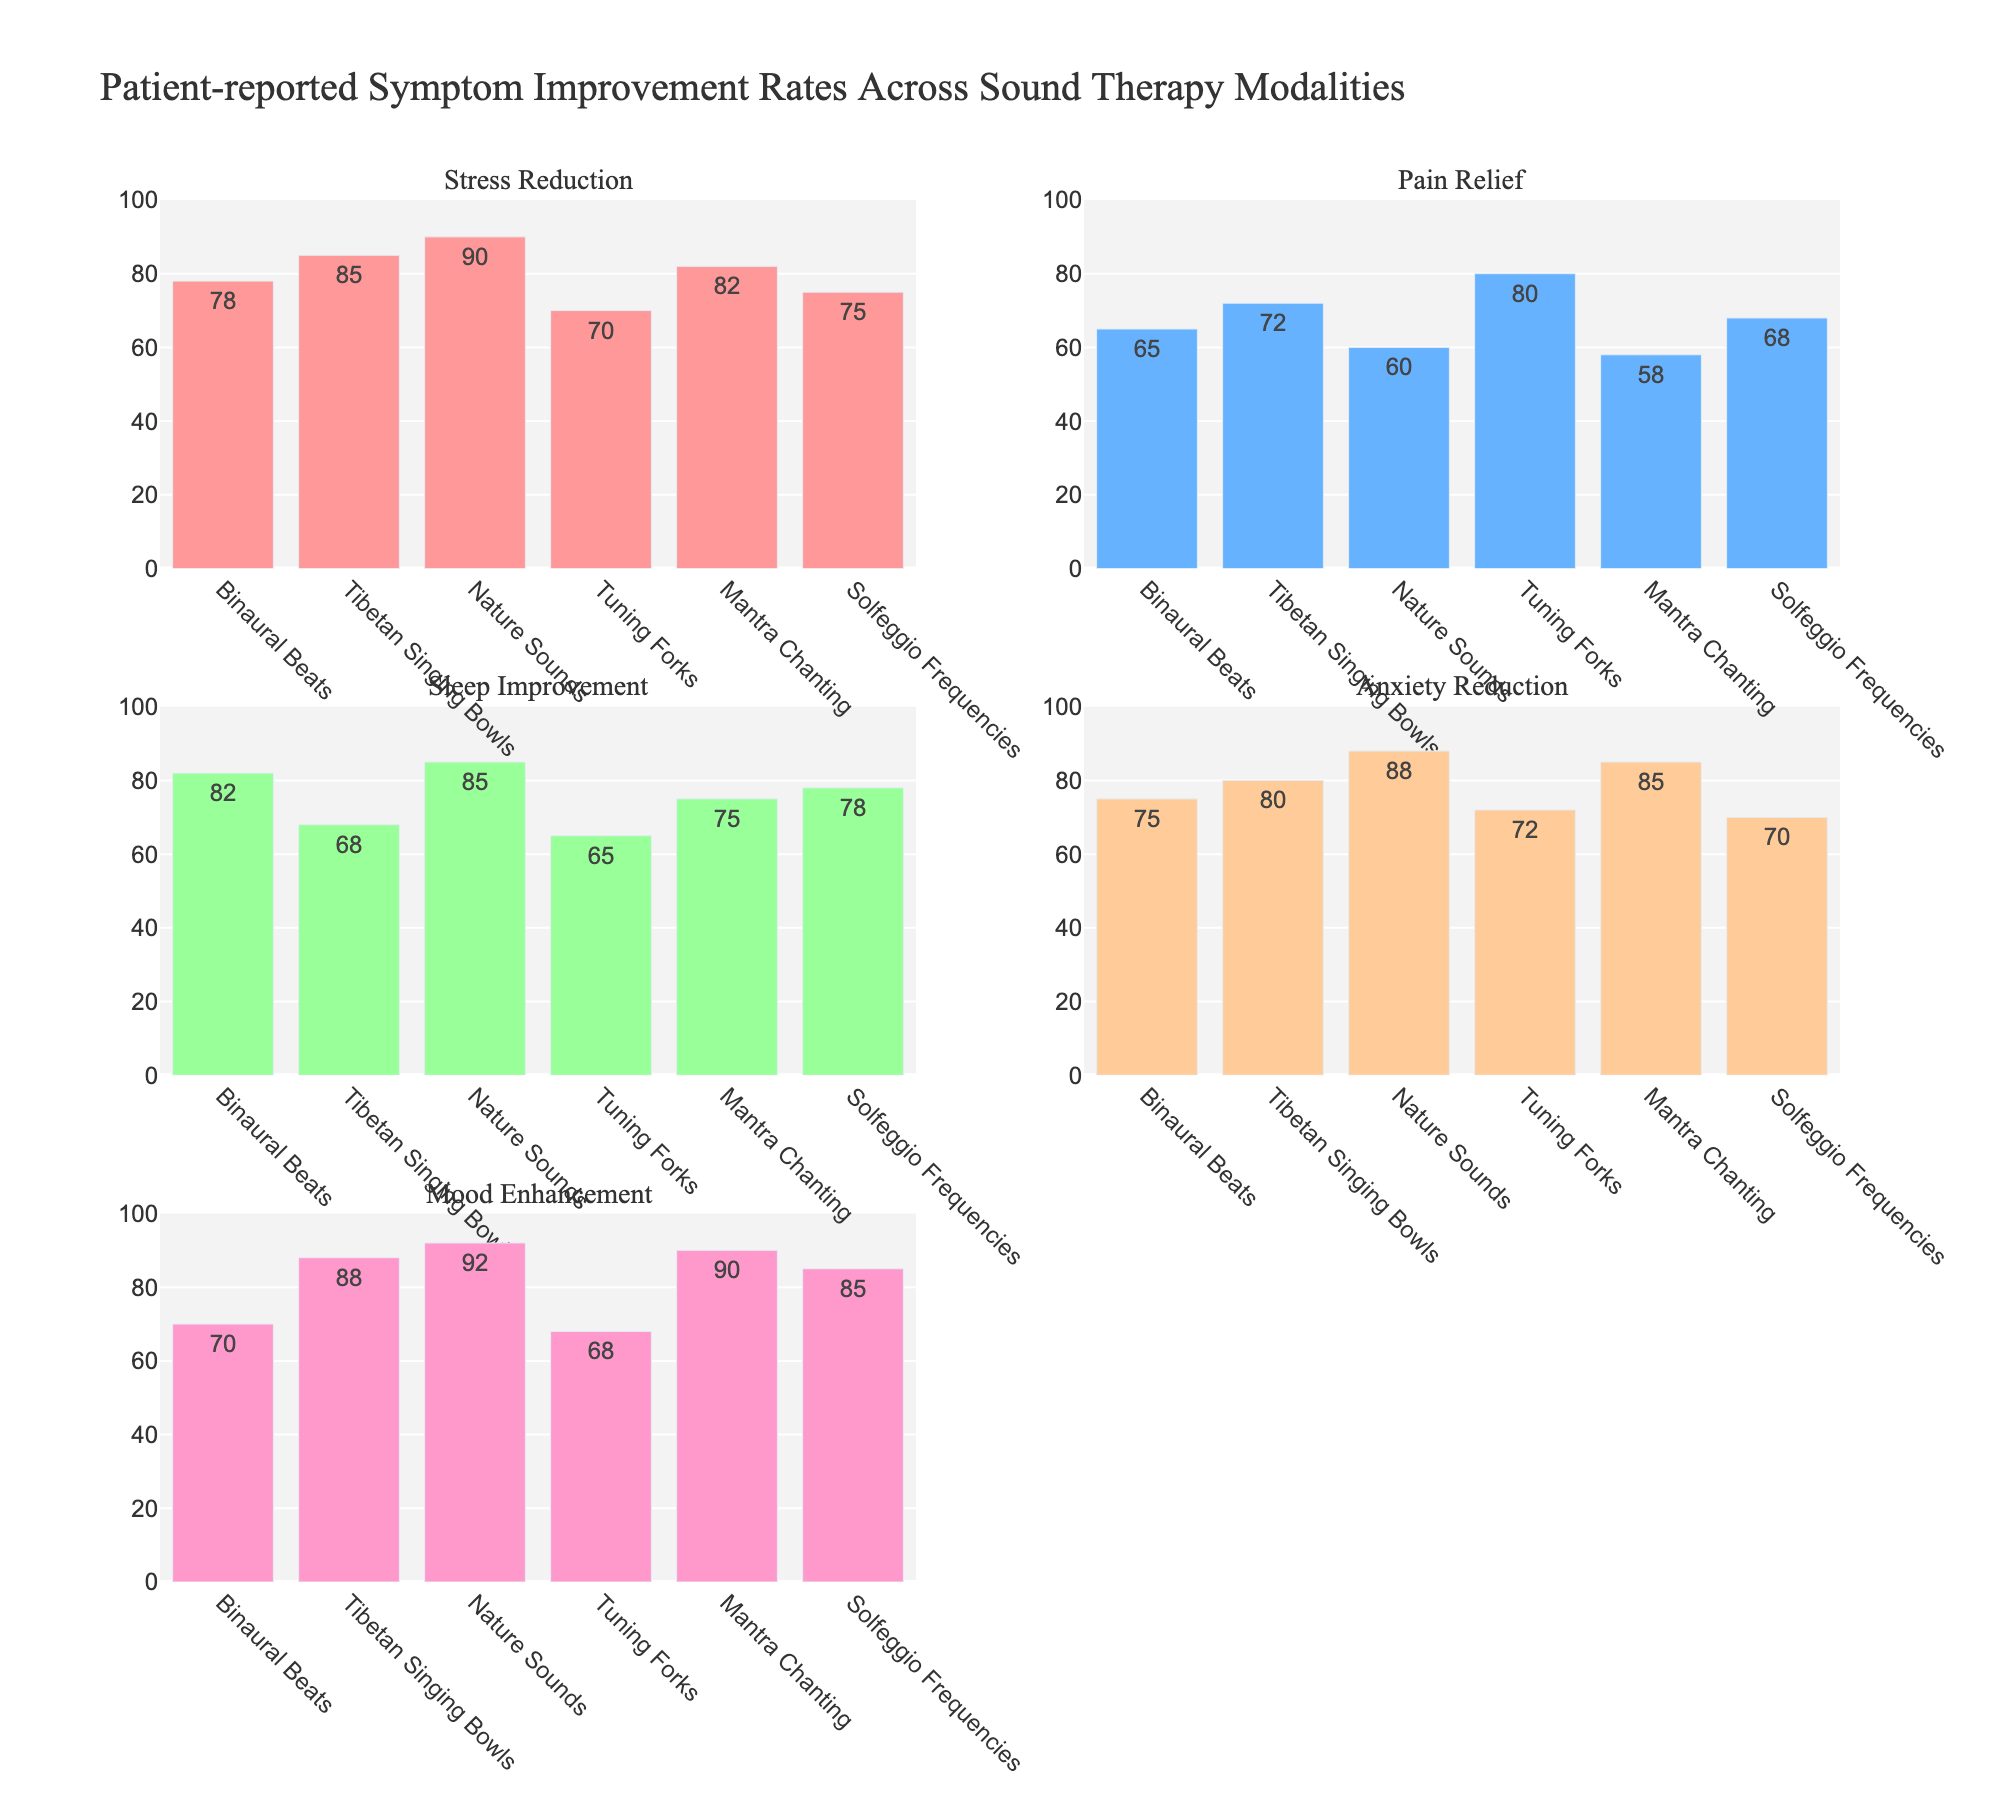What is the overall title of the figure? The overall title is displayed prominently at the top of the figure and summarizes the content of the subplots.
Answer: Patient-reported Symptom Improvement Rates Across Sound Therapy Modalities Which modality has the highest improvement rate for Stress Reduction? To determine the highest improvement rate for Stress Reduction, observe the first subplot. Find the tallest bar, which corresponds to the modality with the highest rate.
Answer: Nature Sounds How many subplots are in the figure? Counting each individual bar chart within the figure helps to determine the total number of subplots.
Answer: 5 Which modality shows the lowest improvement rate for Mood Enhancement? In the Mood Enhancement subplot, identify the shortest bar to determine the modality with the lowest improvement rate.
Answer: Tuning Forks Which symptoms are displayed in the second column of the subplots? The second column contains two subplots. By examining their titles, we can identify which symptoms they represent.
Answer: Pain Relief and Anxiety Reduction What is the average improvement rate for Sleep Improvement across all modalities? Add up all the improvement rates for Sleep Improvement from each modality and divide by the total number of modalities. (82 + 68 + 85 + 65 + 75 + 78) / 6 = 453 / 6
Answer: 75.5% How does the improvement rate for Pain Relief compare between Tibetan Singing Bowls and Tuning Forks? Look at the Pain Relief subplot and compare the heights of the bars for Tibetan Singing Bowls and Tuning Forks.
Answer: Tuning Forks has a higher rate (80) compared to Tibetan Singing Bowls (72) Which modality has consistently high improvement rates across all symptoms? By observing each subplot, look for the modality that consistently has tall bars across all symptoms. Identify the modality with consistently high values in each subplot.
Answer: Nature Sounds Which symptom has the smallest range of improvement rates among all modalities? Calculate the range of improvement rates for each symptom by subtracting the smallest rate from the largest rate. Identify the symptom with the smallest difference.
Answer: Mood Enhancement (24) If you were to recommend a sound therapy modality for Panic attacks based on Anxiety Reduction rates, which one would you choose? Look at the Anxiety Reduction subplot and identify the modality with the highest improvement rate, as it would likely be the most effective.
Answer: Nature Sounds 